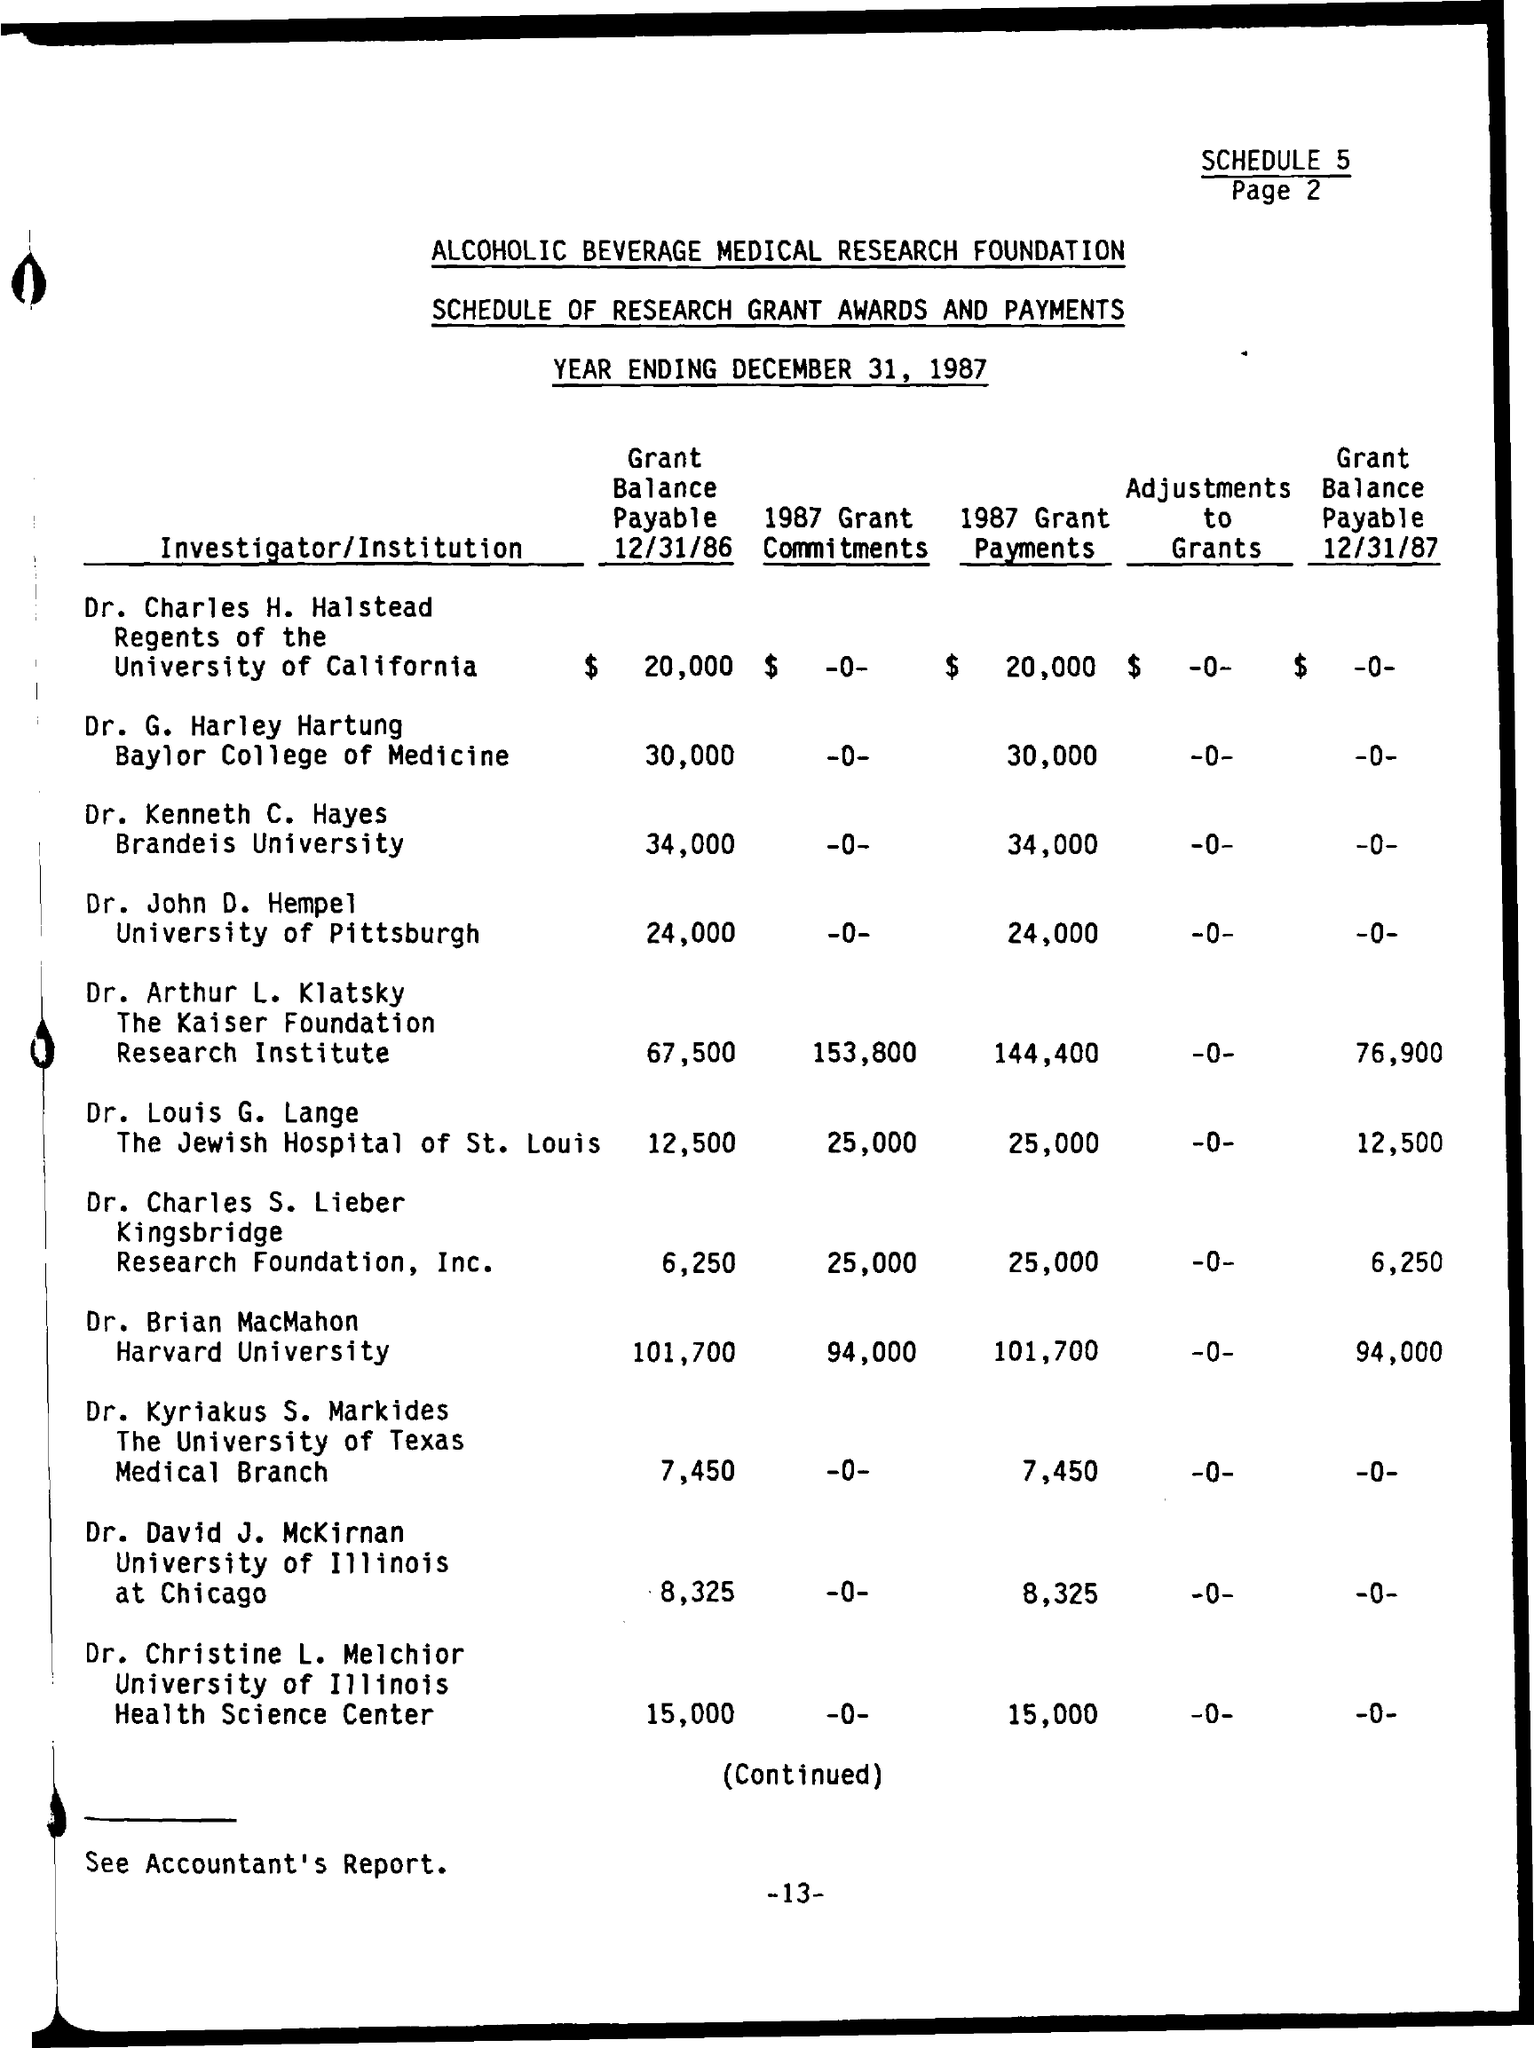Indicate a few pertinent items in this graphic. On December 31, 1987, the year will come to an end. 